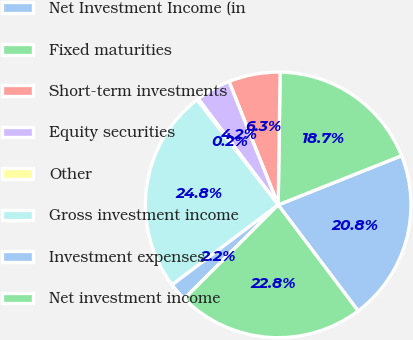<chart> <loc_0><loc_0><loc_500><loc_500><pie_chart><fcel>Net Investment Income (in<fcel>Fixed maturities<fcel>Short-term investments<fcel>Equity securities<fcel>Other<fcel>Gross investment income<fcel>Investment expenses<fcel>Net investment income<nl><fcel>20.76%<fcel>18.73%<fcel>6.27%<fcel>4.24%<fcel>0.19%<fcel>24.81%<fcel>2.22%<fcel>22.78%<nl></chart> 